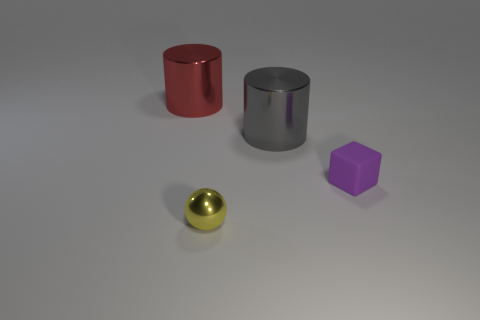Is there anything else that is the same material as the purple object?
Your response must be concise. No. How big is the object to the left of the tiny yellow metallic thing?
Offer a very short reply. Large. Is there a red shiny object of the same shape as the large gray shiny thing?
Ensure brevity in your answer.  Yes. What is the size of the thing behind the metal cylinder that is right of the big red cylinder?
Provide a succinct answer. Large. How many shiny things are cylinders or small yellow things?
Provide a short and direct response. 3. What number of tiny cyan rubber objects are there?
Your answer should be very brief. 0. Is the material of the large thing to the left of the gray shiny object the same as the purple object that is right of the gray cylinder?
Offer a terse response. No. What color is the other metal object that is the same shape as the red thing?
Offer a terse response. Gray. What is the cylinder that is in front of the large thing behind the gray thing made of?
Provide a short and direct response. Metal. Does the large shiny object that is left of the tiny yellow ball have the same shape as the large metal object that is on the right side of the small sphere?
Ensure brevity in your answer.  Yes. 